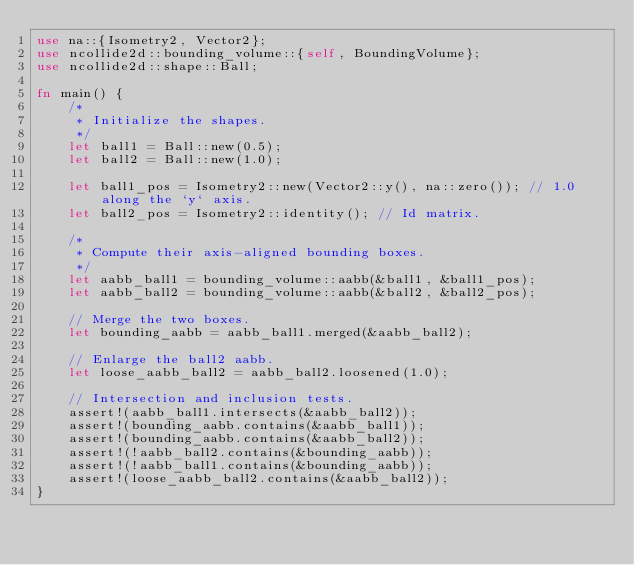Convert code to text. <code><loc_0><loc_0><loc_500><loc_500><_Rust_>use na::{Isometry2, Vector2};
use ncollide2d::bounding_volume::{self, BoundingVolume};
use ncollide2d::shape::Ball;

fn main() {
    /*
     * Initialize the shapes.
     */
    let ball1 = Ball::new(0.5);
    let ball2 = Ball::new(1.0);

    let ball1_pos = Isometry2::new(Vector2::y(), na::zero()); // 1.0 along the `y` axis.
    let ball2_pos = Isometry2::identity(); // Id matrix.

    /*
     * Compute their axis-aligned bounding boxes.
     */
    let aabb_ball1 = bounding_volume::aabb(&ball1, &ball1_pos);
    let aabb_ball2 = bounding_volume::aabb(&ball2, &ball2_pos);

    // Merge the two boxes.
    let bounding_aabb = aabb_ball1.merged(&aabb_ball2);

    // Enlarge the ball2 aabb.
    let loose_aabb_ball2 = aabb_ball2.loosened(1.0);

    // Intersection and inclusion tests.
    assert!(aabb_ball1.intersects(&aabb_ball2));
    assert!(bounding_aabb.contains(&aabb_ball1));
    assert!(bounding_aabb.contains(&aabb_ball2));
    assert!(!aabb_ball2.contains(&bounding_aabb));
    assert!(!aabb_ball1.contains(&bounding_aabb));
    assert!(loose_aabb_ball2.contains(&aabb_ball2));
}
</code> 